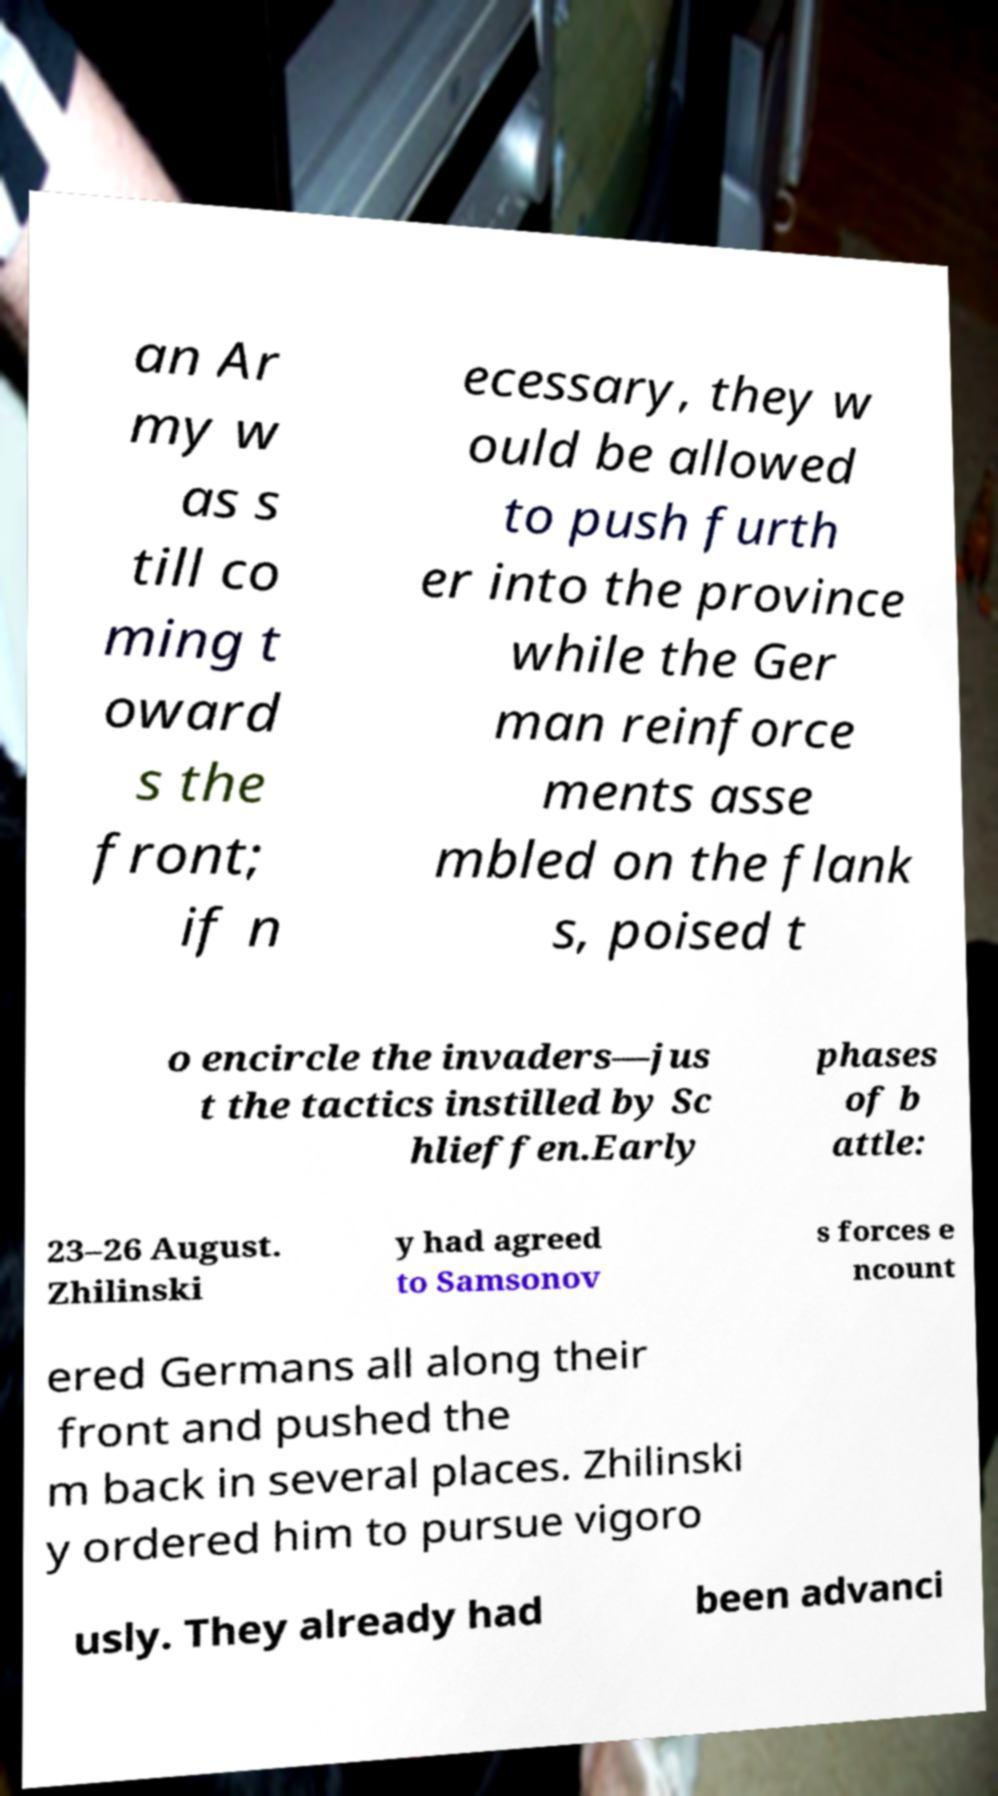What messages or text are displayed in this image? I need them in a readable, typed format. an Ar my w as s till co ming t oward s the front; if n ecessary, they w ould be allowed to push furth er into the province while the Ger man reinforce ments asse mbled on the flank s, poised t o encircle the invaders—jus t the tactics instilled by Sc hlieffen.Early phases of b attle: 23–26 August. Zhilinski y had agreed to Samsonov s forces e ncount ered Germans all along their front and pushed the m back in several places. Zhilinski y ordered him to pursue vigoro usly. They already had been advanci 